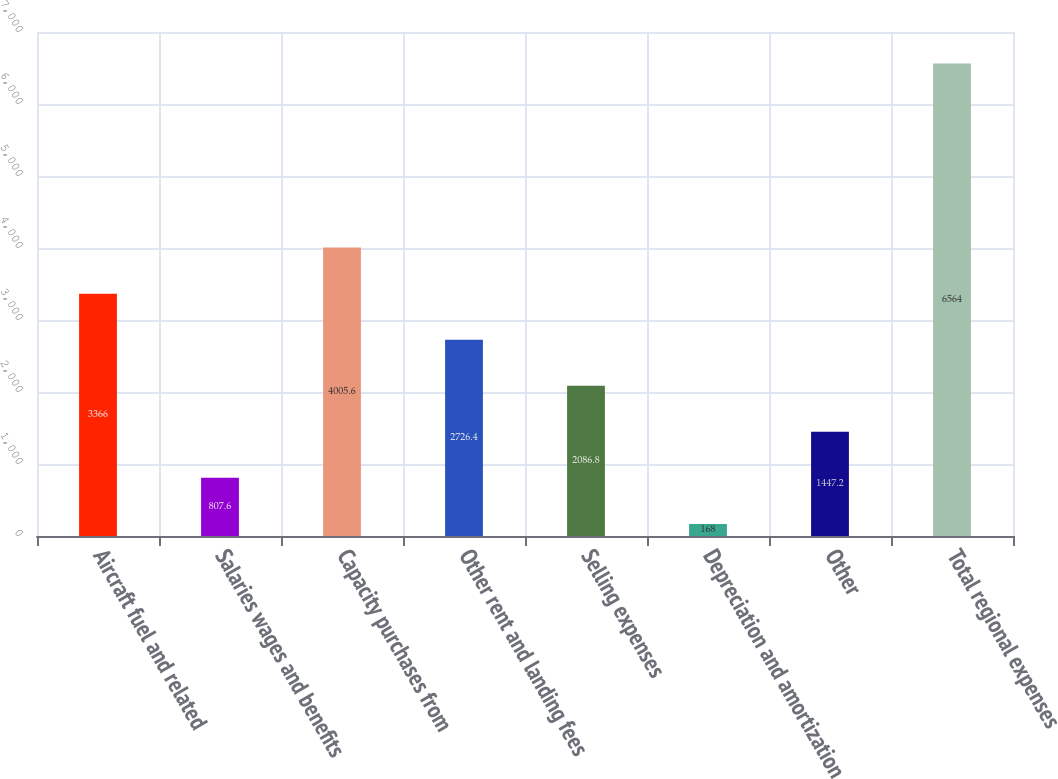Convert chart to OTSL. <chart><loc_0><loc_0><loc_500><loc_500><bar_chart><fcel>Aircraft fuel and related<fcel>Salaries wages and benefits<fcel>Capacity purchases from<fcel>Other rent and landing fees<fcel>Selling expenses<fcel>Depreciation and amortization<fcel>Other<fcel>Total regional expenses<nl><fcel>3366<fcel>807.6<fcel>4005.6<fcel>2726.4<fcel>2086.8<fcel>168<fcel>1447.2<fcel>6564<nl></chart> 